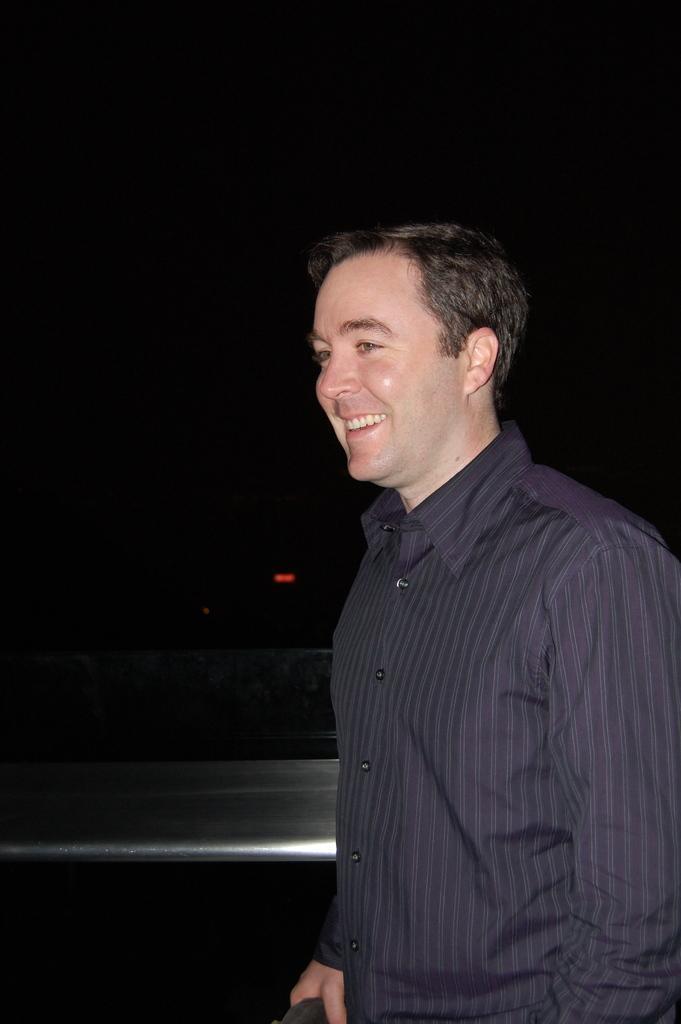Describe this image in one or two sentences. This image consists of a man wearing a purple shirt. Beside him, there is a railing made up of metal. The background is too dark. 